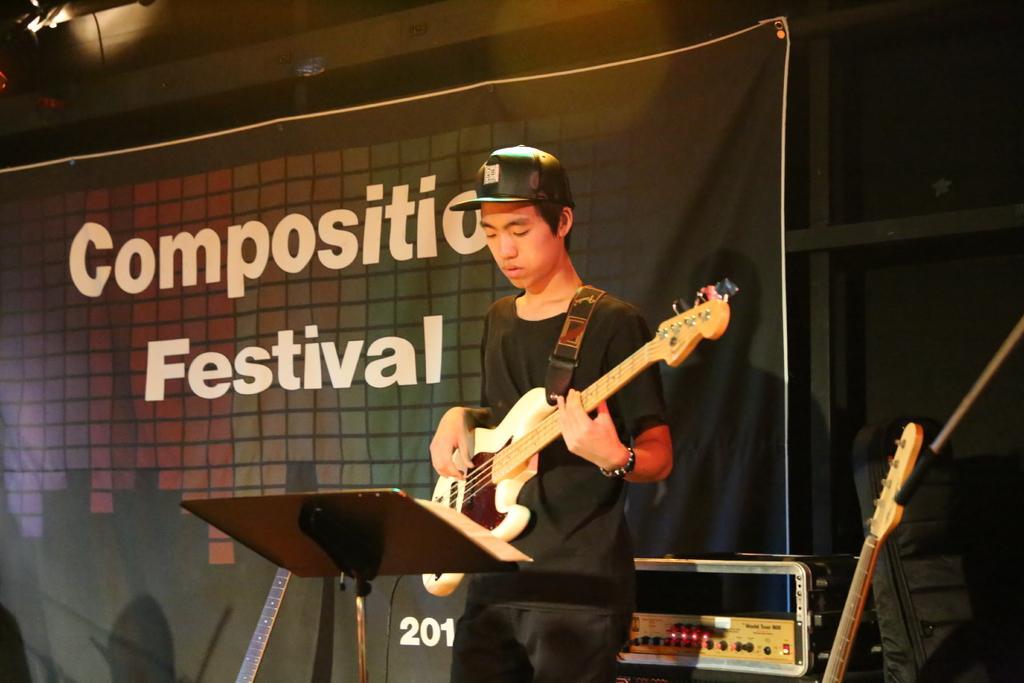In one or two sentences, can you explain what this image depicts? In this picture we can see a person playing guitar. There is a stand. We can see a device on the right side. There are some lights on top. 